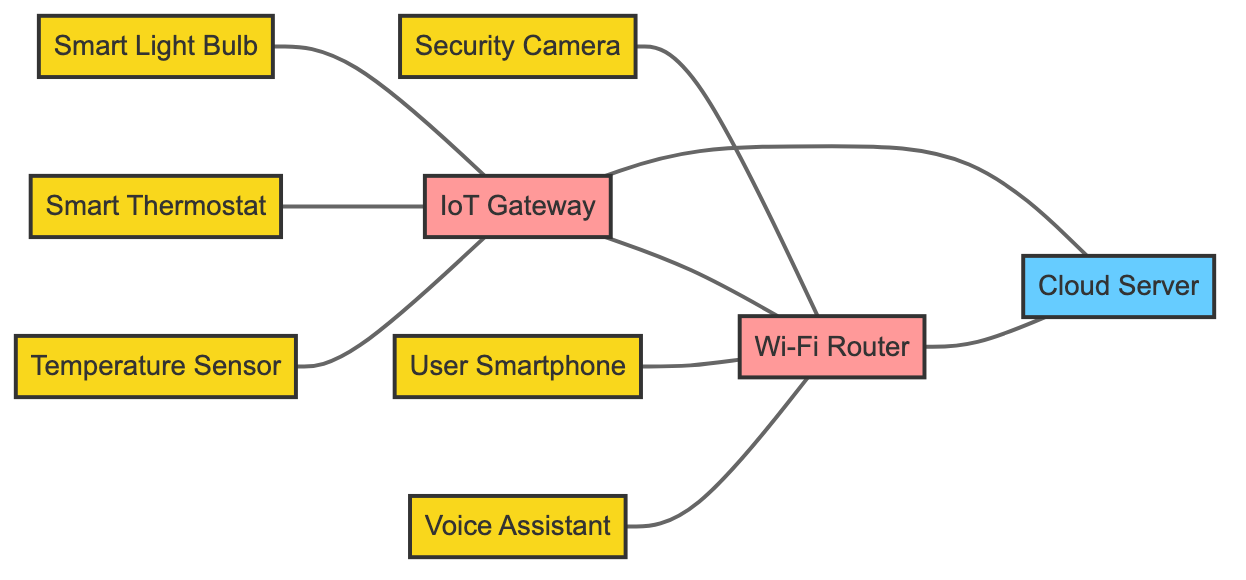What is the total number of nodes in the diagram? The nodes in the diagram consist of the Temperature Sensor, Smart Thermostat, Security Camera, IoT Gateway, User Smartphone, Wi-Fi Router, Cloud Server, Voice Assistant, and Smart Light Bulb. Counting these, we find there are a total of 9 unique nodes.
Answer: 9 Which device is directly connected to the IoT Gateway? The Temperature Sensor, Smart Thermostat, and Smart Light Bulb are all directly connected to the IoT Gateway. Therefore, there are three devices connected to it.
Answer: Temperature Sensor, Smart Thermostat, Smart Light Bulb What connection exists between the Security Camera and the Cloud Server? The Security Camera is connected indirectly through the Wi-Fi Router and the IoT Gateway. Since there is no direct edge shown in the diagram connecting the Security Camera to the Cloud Server, the connection is indirect and requires the router and gateway for data flow.
Answer: Indirect connection via Router and Gateway How many devices connect to the Wi-Fi Router? The devices connected to the Wi-Fi Router are the Security Camera, IoT Gateway, User Smartphone, and Voice Assistant. Counting these, there are four devices that connect to it.
Answer: 4 Which nodes form a direct communication link with the Cloud Server? The nodes that have a direct communication link with the Cloud Server are the Wi-Fi Router and the IoT Gateway. The edges directly linking them indicate clear communication paths ending at the Cloud Server.
Answer: IoT Gateway, Wi-Fi Router Does the Voice Assistant have a direct connection to the Cloud Server? The Voice Assistant does not have a direct edge connecting it to the Cloud Server; it connects only to the Wi-Fi Router. Hence, communication to the Cloud Server is through the router, making it indirect.
Answer: No Which device serves as the central hub among the nodes in this diagram? The IoT Gateway serves as the central hub because it connects multiple devices (Temperature Sensor, Smart Thermostat, and Smart Light Bulb) with the Wi-Fi Router, facilitating data interchange within the system.
Answer: IoT Gateway What is the relationship between the User Smartphone and the IoT devices in this setup? The User Smartphone is linked to the Wi-Fi Router, enabling communication with multiple IoT devices. This indicates it acts as a command interface or monitoring device for the smart home setup, allowing user interaction with the IoT network.
Answer: Monitoring device How many edges are there in total in the diagram? The edges represent the communication links between nodes. Counting the lines specified in the edges list, we find that there are a total of 8 edges connecting the devices in the diagram.
Answer: 8 